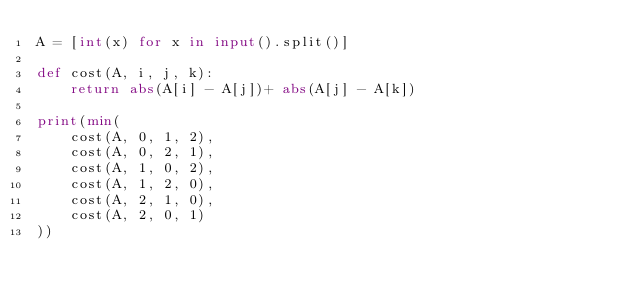Convert code to text. <code><loc_0><loc_0><loc_500><loc_500><_Python_>A = [int(x) for x in input().split()]

def cost(A, i, j, k):
    return abs(A[i] - A[j])+ abs(A[j] - A[k])

print(min(
    cost(A, 0, 1, 2),
    cost(A, 0, 2, 1),
    cost(A, 1, 0, 2),
    cost(A, 1, 2, 0),
    cost(A, 2, 1, 0),
    cost(A, 2, 0, 1)
))
    
</code> 